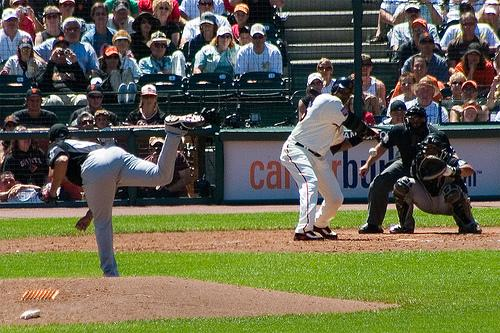What is the sponsor's industry?

Choices:
A) automotive
B) job search
C) electronics
D) clothing job search 